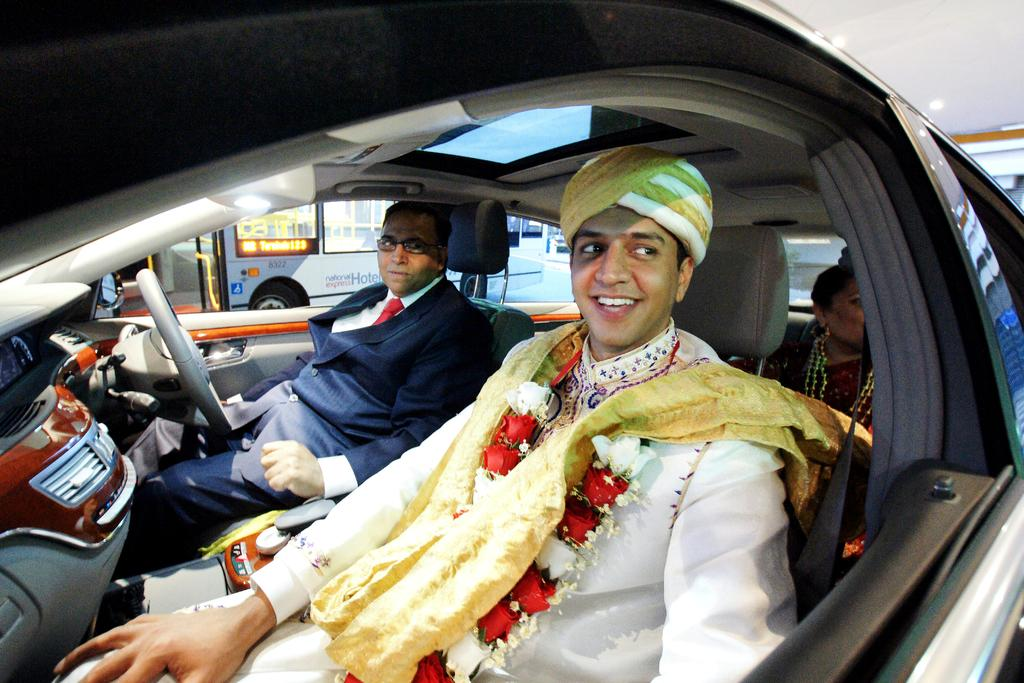How many people are in the car in the image? There are three persons in the car. What are the people in the car doing? The persons are sitting in the car and smiling. Can you describe the appearance of the person in the front? The front person is wearing a hat. What can be seen in the background of the image? There is a bus and a road in the background. How does the crowd help the person on the island in the image? There is no crowd or person on an island present in the image. 